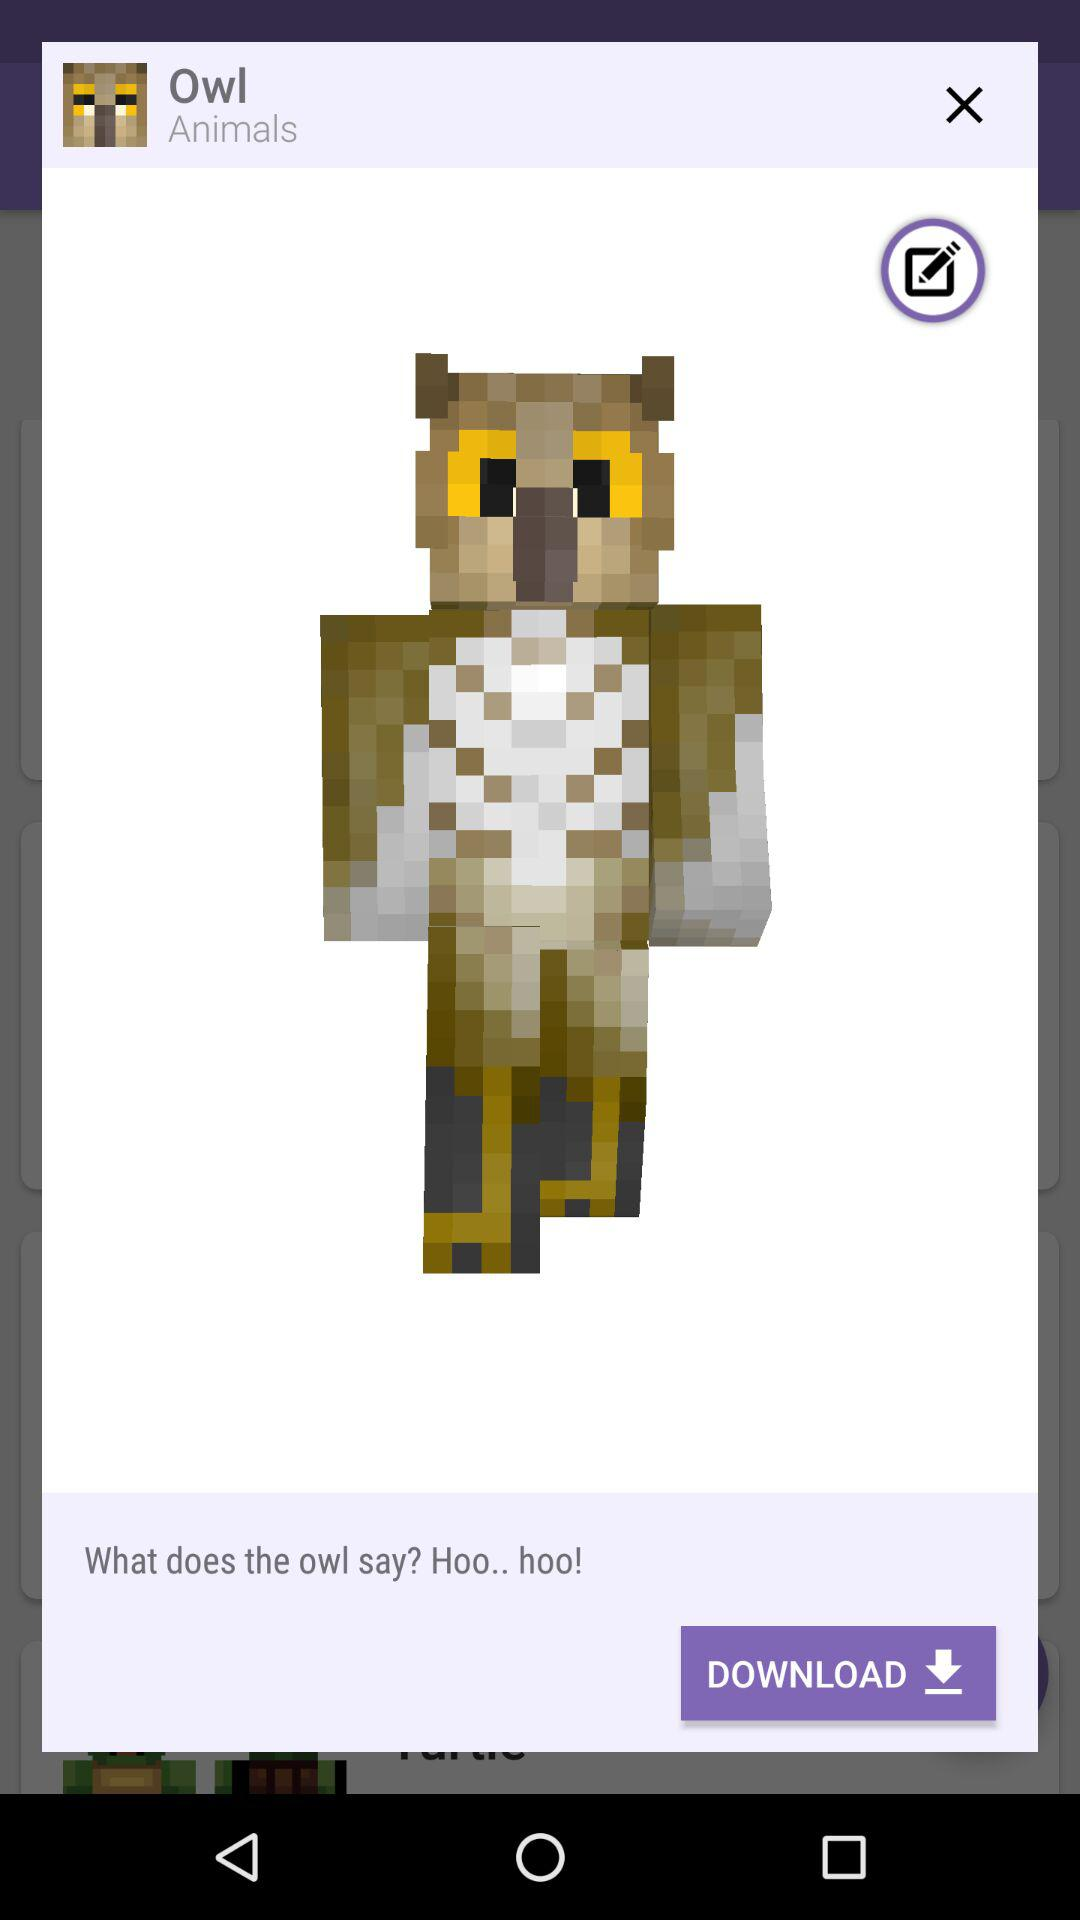What does the owl say? The owl says "Hoo.. hoo!". 